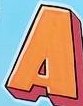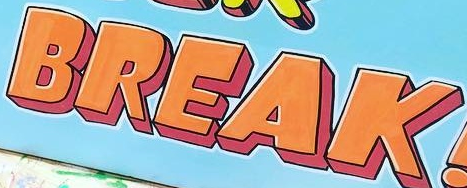Identify the words shown in these images in order, separated by a semicolon. A; BREAK 